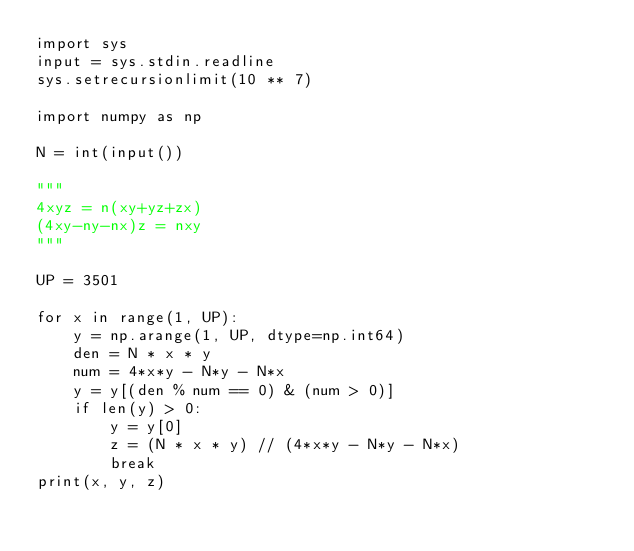Convert code to text. <code><loc_0><loc_0><loc_500><loc_500><_Python_>import sys
input = sys.stdin.readline
sys.setrecursionlimit(10 ** 7)

import numpy as np

N = int(input())

"""
4xyz = n(xy+yz+zx)
(4xy-ny-nx)z = nxy
"""

UP = 3501

for x in range(1, UP):
    y = np.arange(1, UP, dtype=np.int64)
    den = N * x * y
    num = 4*x*y - N*y - N*x
    y = y[(den % num == 0) & (num > 0)]
    if len(y) > 0:
        y = y[0]
        z = (N * x * y) // (4*x*y - N*y - N*x)
        break
print(x, y, z)</code> 